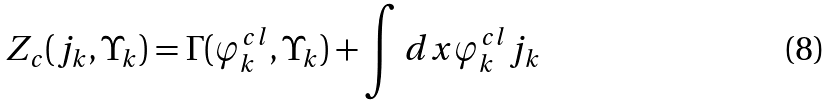Convert formula to latex. <formula><loc_0><loc_0><loc_500><loc_500>Z _ { c } ( j _ { k } , \Upsilon _ { k } ) = \Gamma ( \varphi _ { k } ^ { c l } , \Upsilon _ { k } ) + \int d x \varphi _ { k } ^ { c l } j _ { k }</formula> 